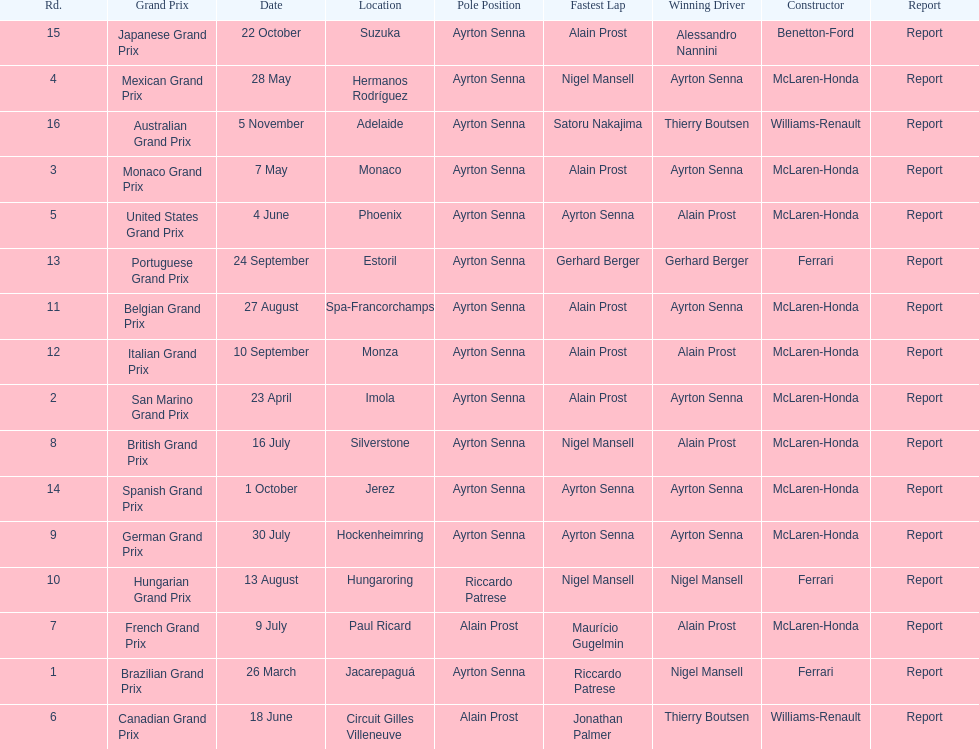How many did alain prost have the fastest lap? 5. 